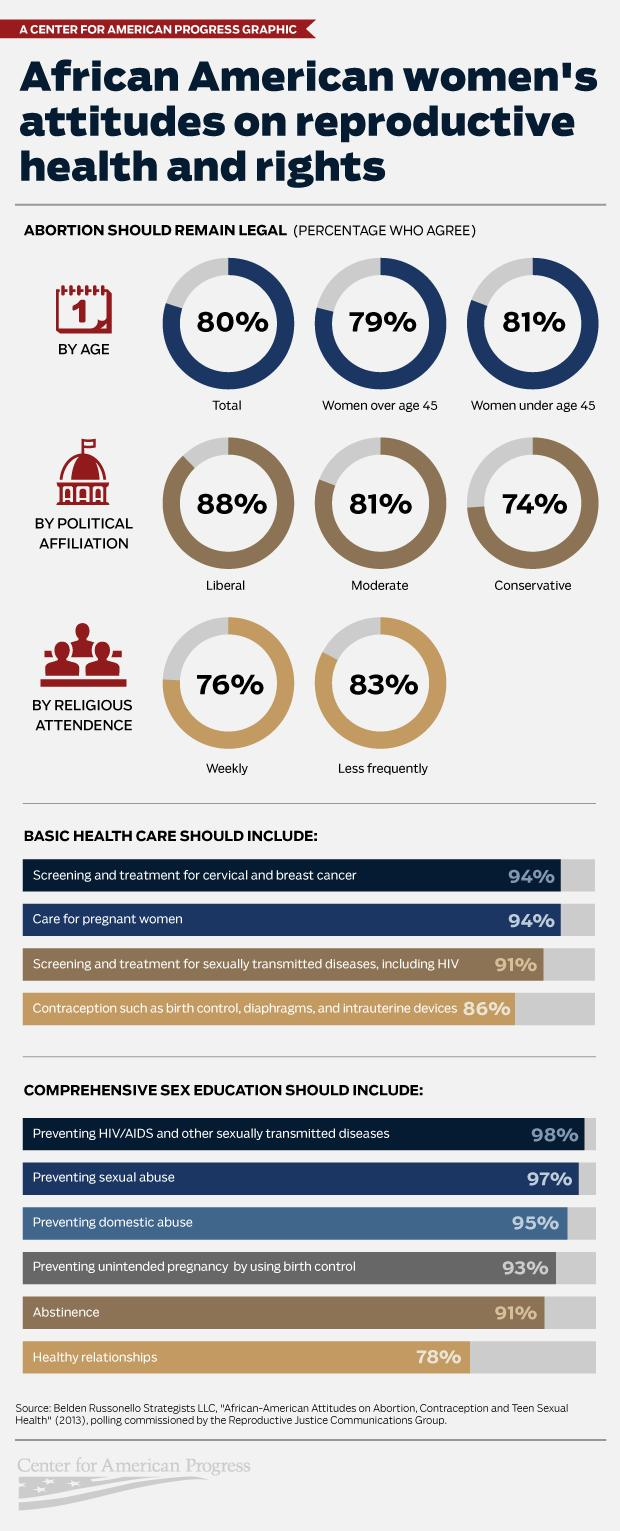List a handful of essential elements in this visual. According to the survey, 81% of African American women under the age of 45 agree that abortion should remain legal. According to a survey of African American women who regularly visit religious places, 76% agree that abortion should remain legal. According to the given percentage, a minority of African American women, at 6%, disagree that basic health care should include screening and treatment for cervical and breast cancer. According to a survey, 79% of African American women over the age of 45 agree that abortion should remain legal. A small percentage of African American women, just 9%, disagree that comprehensive sex education should include abstinence as an option. 